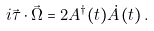<formula> <loc_0><loc_0><loc_500><loc_500>i \vec { \tau } \cdot \vec { \Omega } = 2 A ^ { \dag } ( t ) \dot { A } ( t ) \, .</formula> 